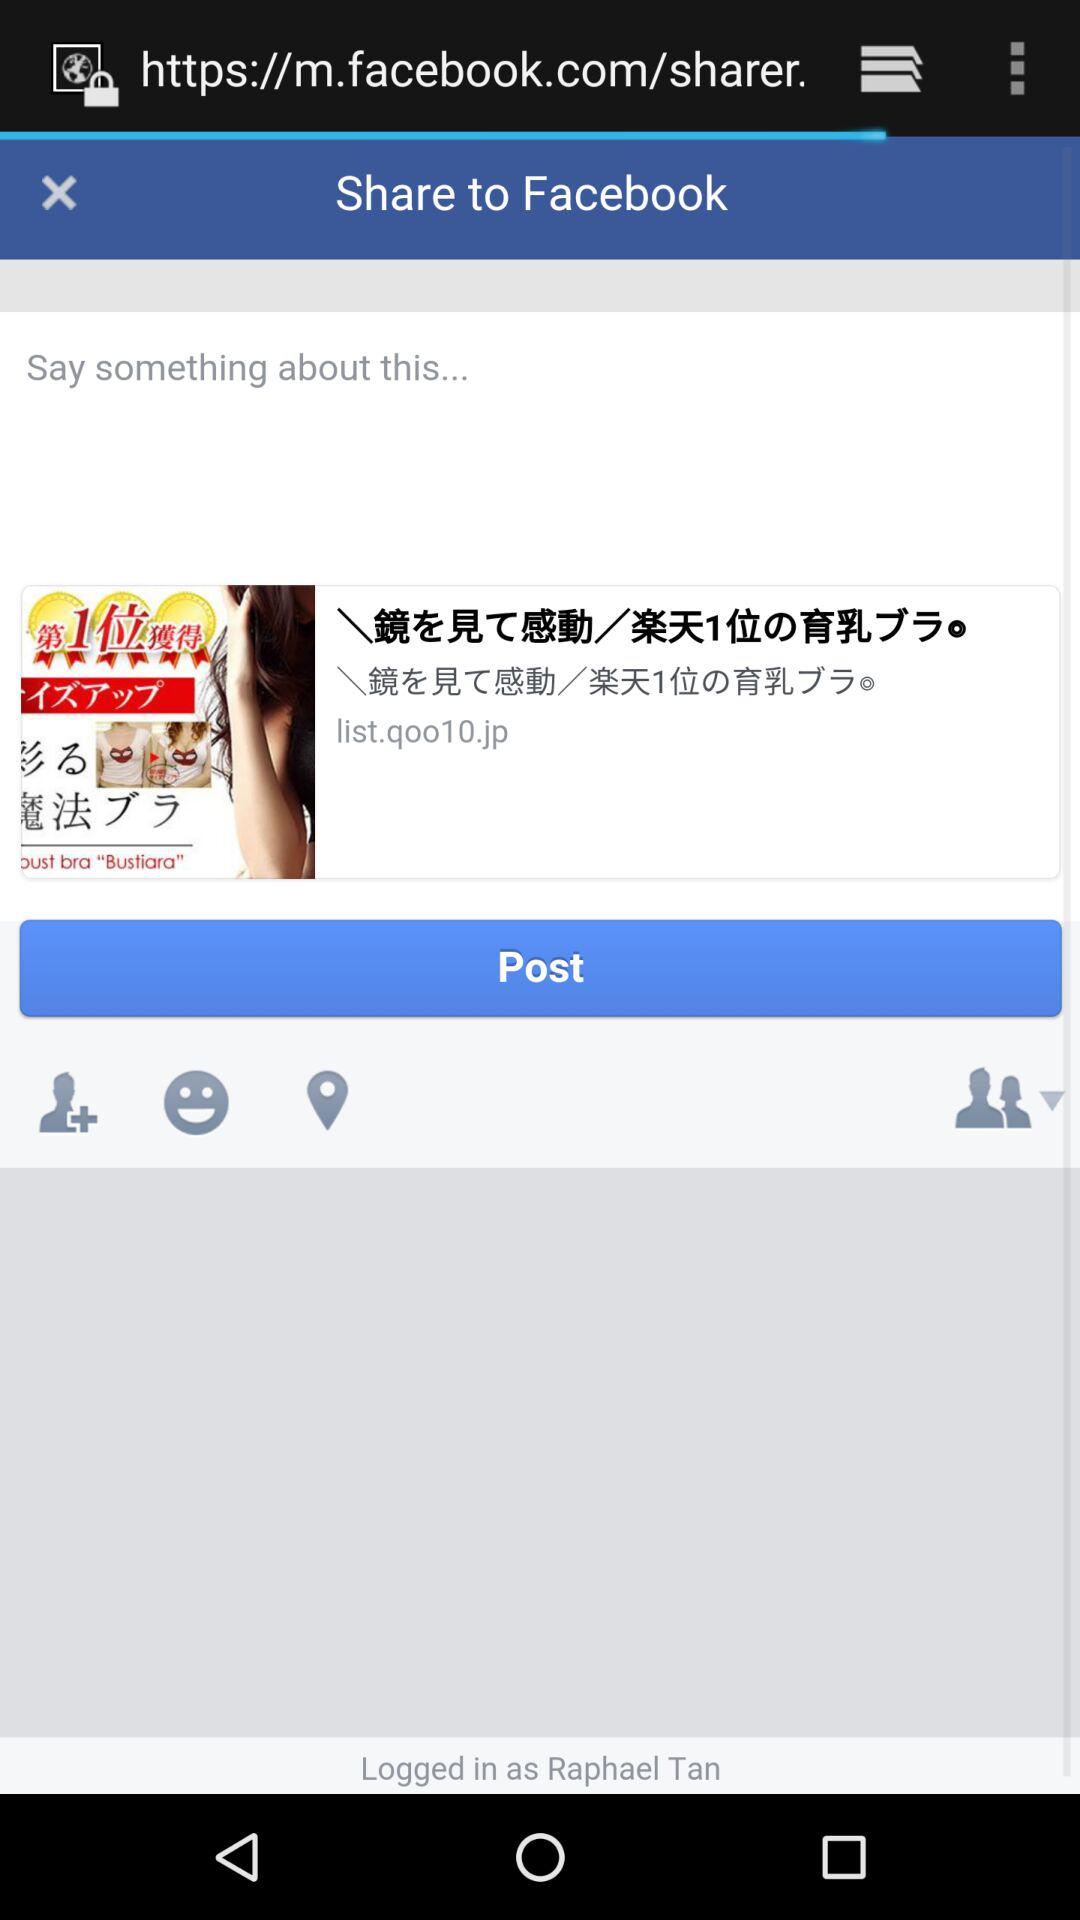What application can be used to share the post? The application is "Facebook". 